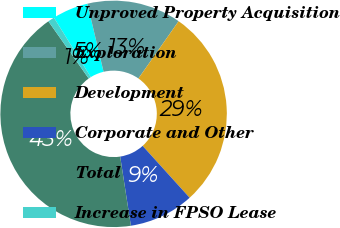<chart> <loc_0><loc_0><loc_500><loc_500><pie_chart><fcel>Unproved Property Acquisition<fcel>Exploration<fcel>Development<fcel>Corporate and Other<fcel>Total<fcel>Increase in FPSO Lease<nl><fcel>5.11%<fcel>13.46%<fcel>28.54%<fcel>9.28%<fcel>42.67%<fcel>0.94%<nl></chart> 